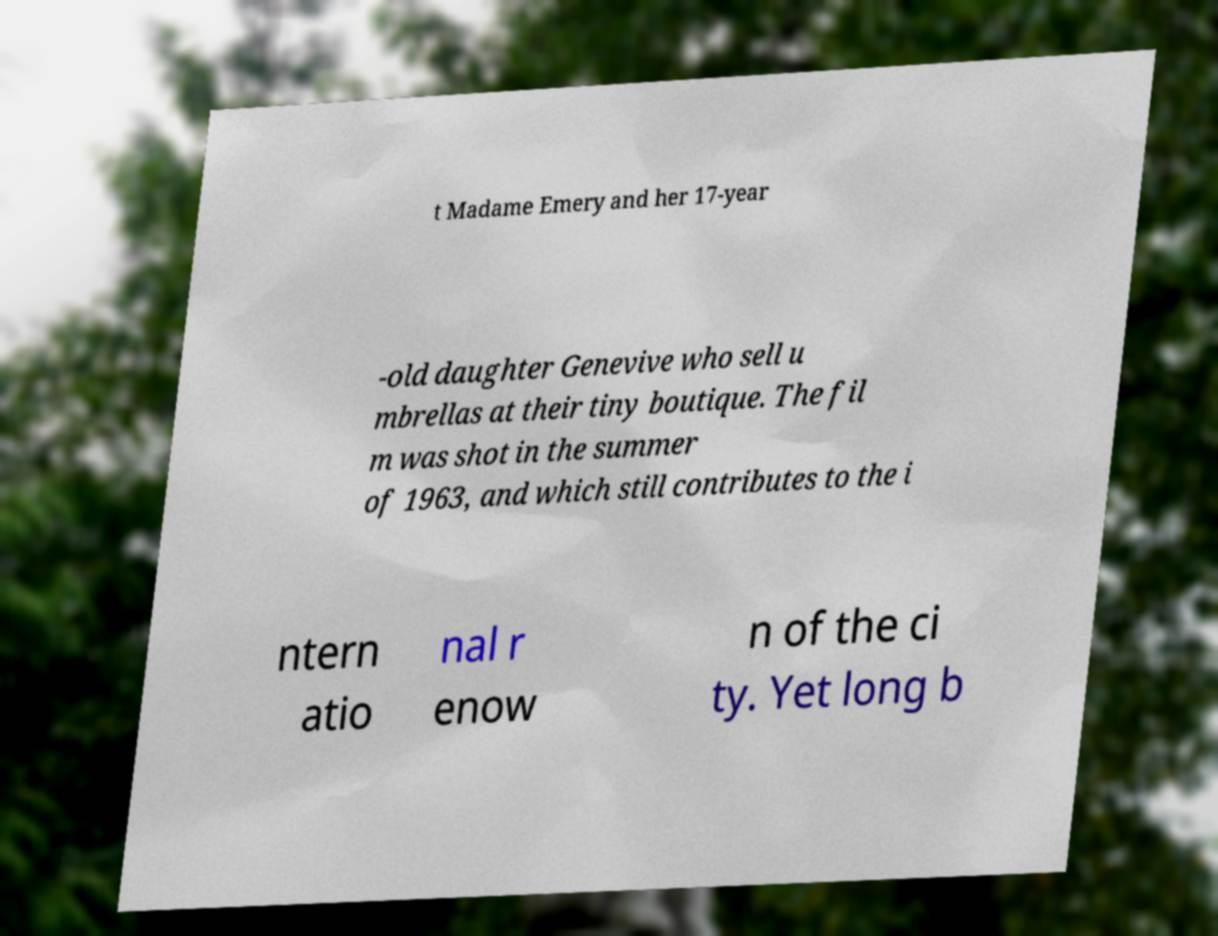I need the written content from this picture converted into text. Can you do that? t Madame Emery and her 17-year -old daughter Genevive who sell u mbrellas at their tiny boutique. The fil m was shot in the summer of 1963, and which still contributes to the i ntern atio nal r enow n of the ci ty. Yet long b 